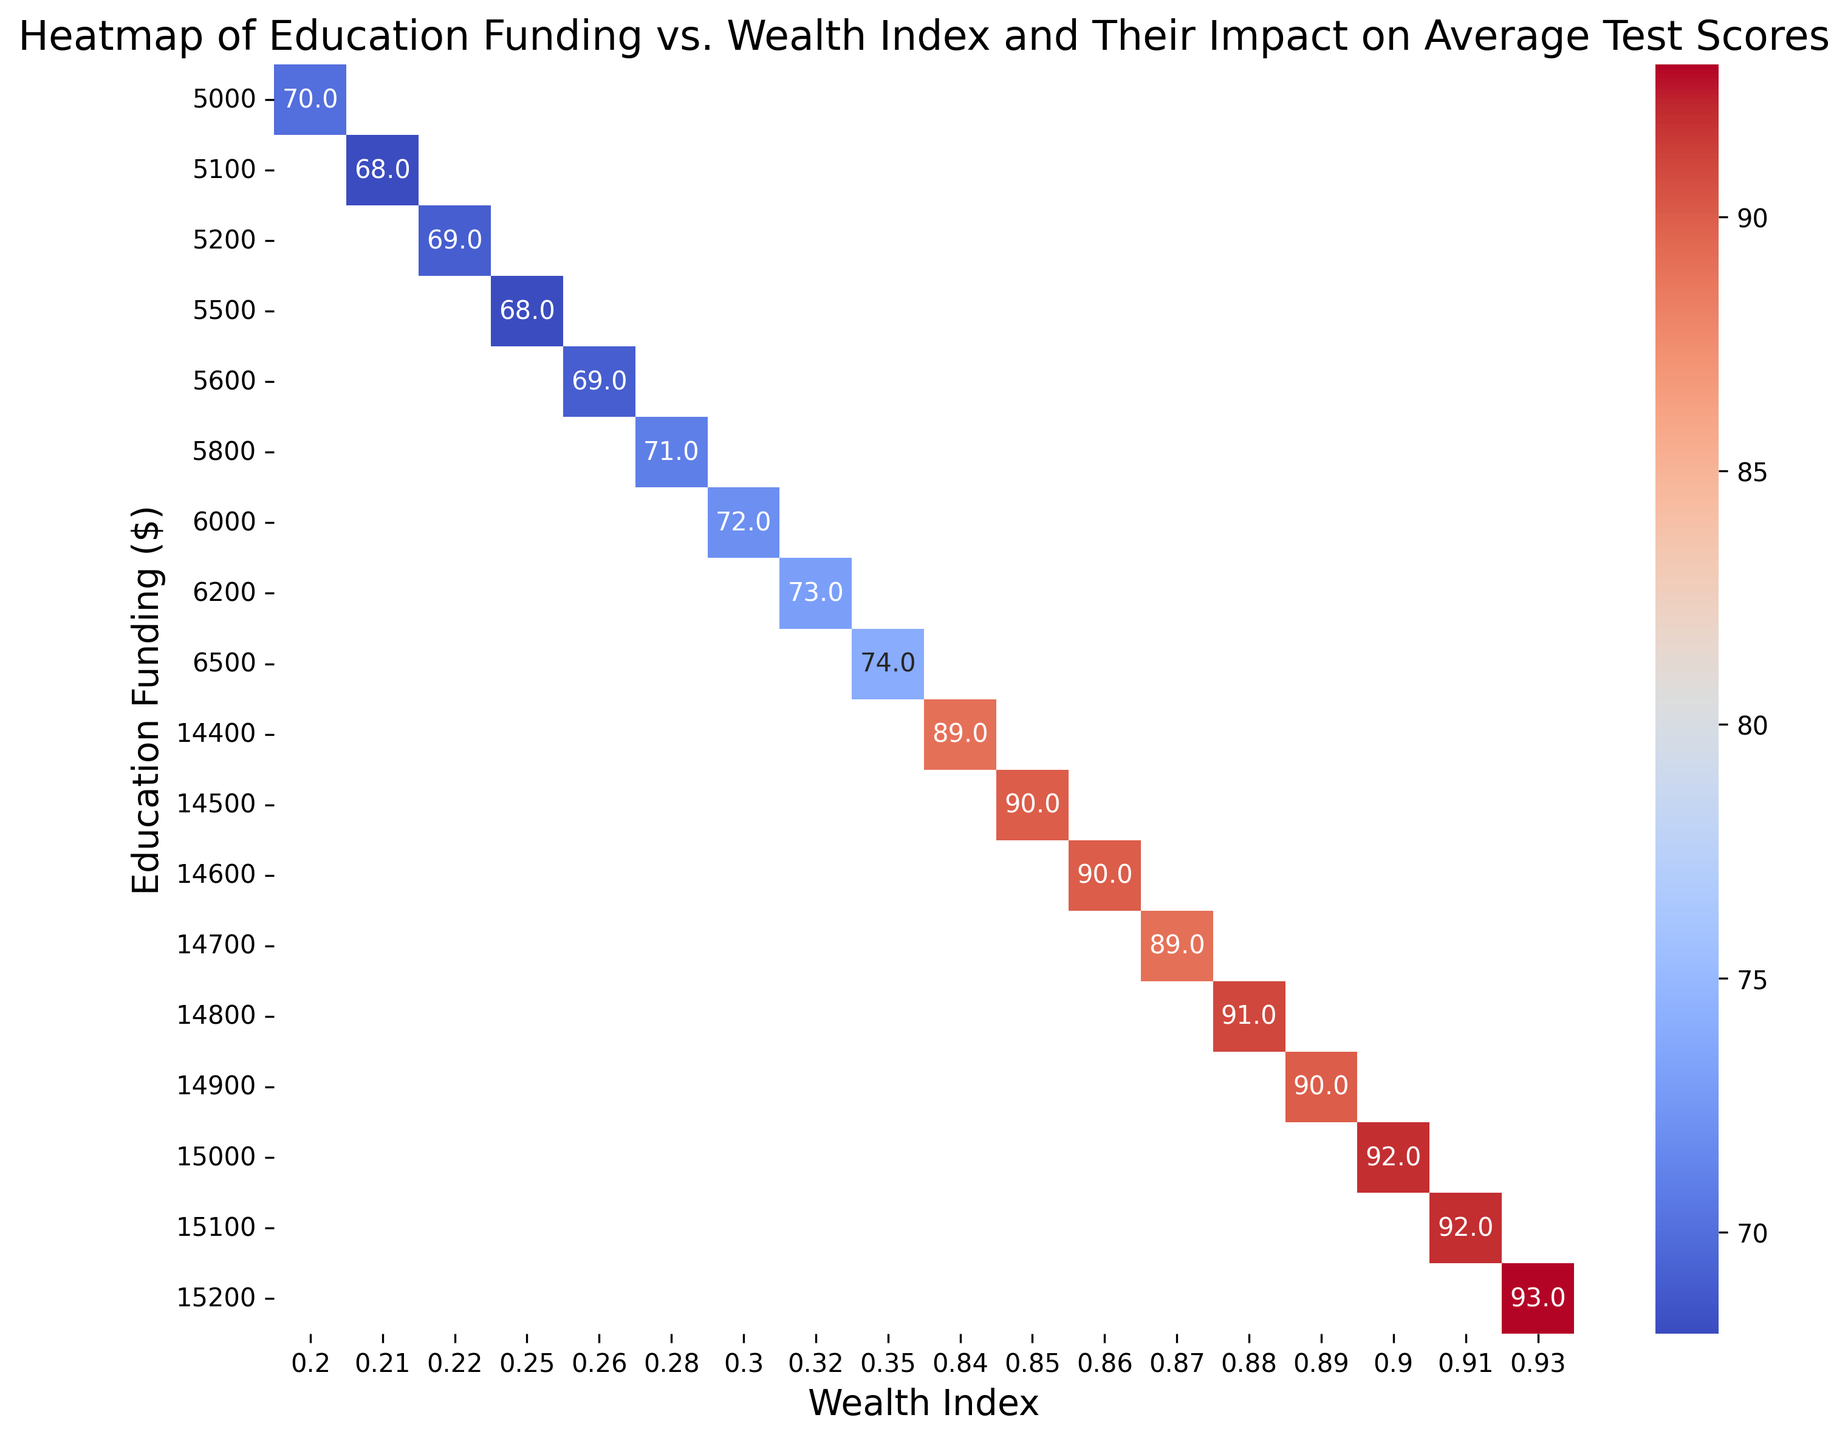what is the average test score for education funding of $5800? On the heatmap, locate the cell corresponding to an education funding of $5800. Check the value in this cell to find the average test score for this funding amount.
Answer: 71 Which wealth index is associated with the highest average test score? On the heatmap, find the cell with the highest numerical value and then identify the corresponding wealth index on the horizontal axis.
Answer: 0.93 What is the difference in average test scores between the wealth indices 0.20 and 0.35 for their respective education funding amounts? Locate the cells corresponding to wealth indices of 0.20 and 0.35. Note the average test scores given their respective education funding amounts. Then, subtract the smaller value from the larger value to find the difference.
Answer: 74 - 70 = 4 Among the wealthy neighborhoods, what is the education funding associated with the lowest test score and what is that score? In the "Wealthy" neighborhood rows, locate the cell with the smallest numerical value on the heatmap, then identify the corresponding education funding and test score.
Answer: $14400, 89 Do all education funding amounts greater than $15000 correspond to wealth indices greater than 0.90? On the heatmap, find cells where education funding is greater than $15000 and check if their corresponding wealth indices are all above 0.90. If all the values matched the criteria, the statement is true.
Answer: Yes What color represents the average test scores around 90? Look at the heatmap and identify the color gradient representing average test scores, focusing on the region around the score of 90 to determine the color.
Answer: Light red/orange Which education funding level has the most variability in average test scores? Observe the range of test scores across various wealth indices for each education funding level. Identify the row with the widest range of values (difference between highest and lowest score).
Answer: $5800 (Values range from 68 to 74) What is the average score for underprivileged neighborhoods with a wealth index of 0.25? Locate the cell corresponding to an underprivileged neighborhood with a wealth index of 0.25 on the heatmap. Check the cell’s value to find the average test score.
Answer: 68 Compare the average test scores for education fundings of $14500 and $14600. Which one is higher? Locate the cells corresponding to education fundings of $14500 and $14600 on the heatmap. Compare the numerical values to identify which one is higher.
Answer: $14500:90, $14600:90, both equal Is there a correlation between wealth index and average test scores in this data set? Observing the general trend on the heatmap, check if higher wealth indices generally correspond to higher average test scores.
Answer: Yes 